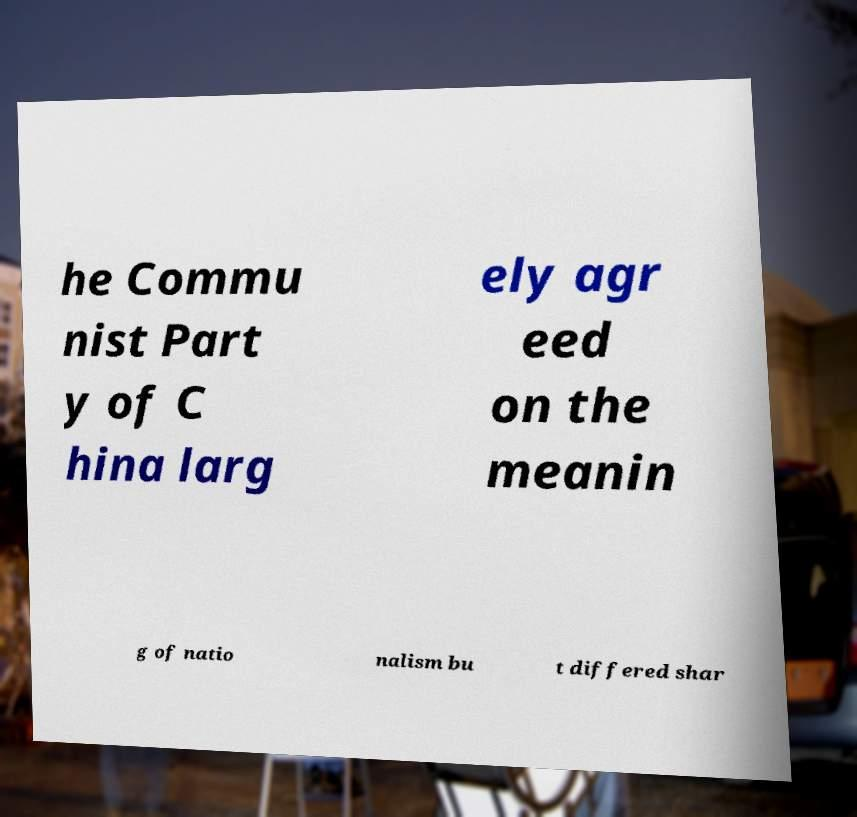There's text embedded in this image that I need extracted. Can you transcribe it verbatim? he Commu nist Part y of C hina larg ely agr eed on the meanin g of natio nalism bu t differed shar 